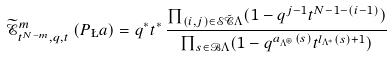Convert formula to latex. <formula><loc_0><loc_0><loc_500><loc_500>\widetilde { \mathcal { E } } _ { t ^ { N - m } , q , t } ^ { m } \left ( P _ { \L } a \right ) = q ^ { * } t ^ { * } \, \frac { \prod _ { ( i , j ) \in \mathcal { S } \tilde { \mathcal { C } } \Lambda } ( 1 - q ^ { j - 1 } t ^ { N - 1 - ( i - 1 ) } ) } { \prod _ { s \in \mathcal { B } \Lambda } ( 1 - q ^ { a _ { \Lambda ^ { \circledast } } ( s ) } t ^ { l _ { \Lambda ^ { * } } ( s ) + 1 } ) }</formula> 